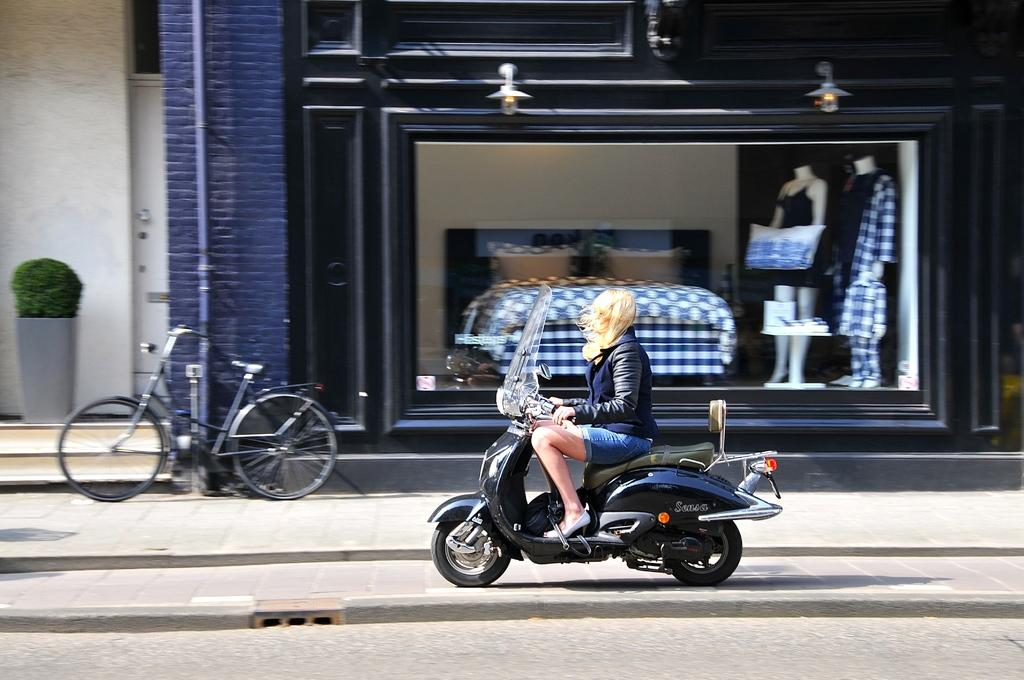What is the person in the image doing? There is a person sitting on a bike in the image. What can be seen in the background of the image? There is a cycle, a plant, two mannequins, and a building in the background of the image. How does the person in the image comb their hair? There is no information about the person's hair or any combing activity in the image. 